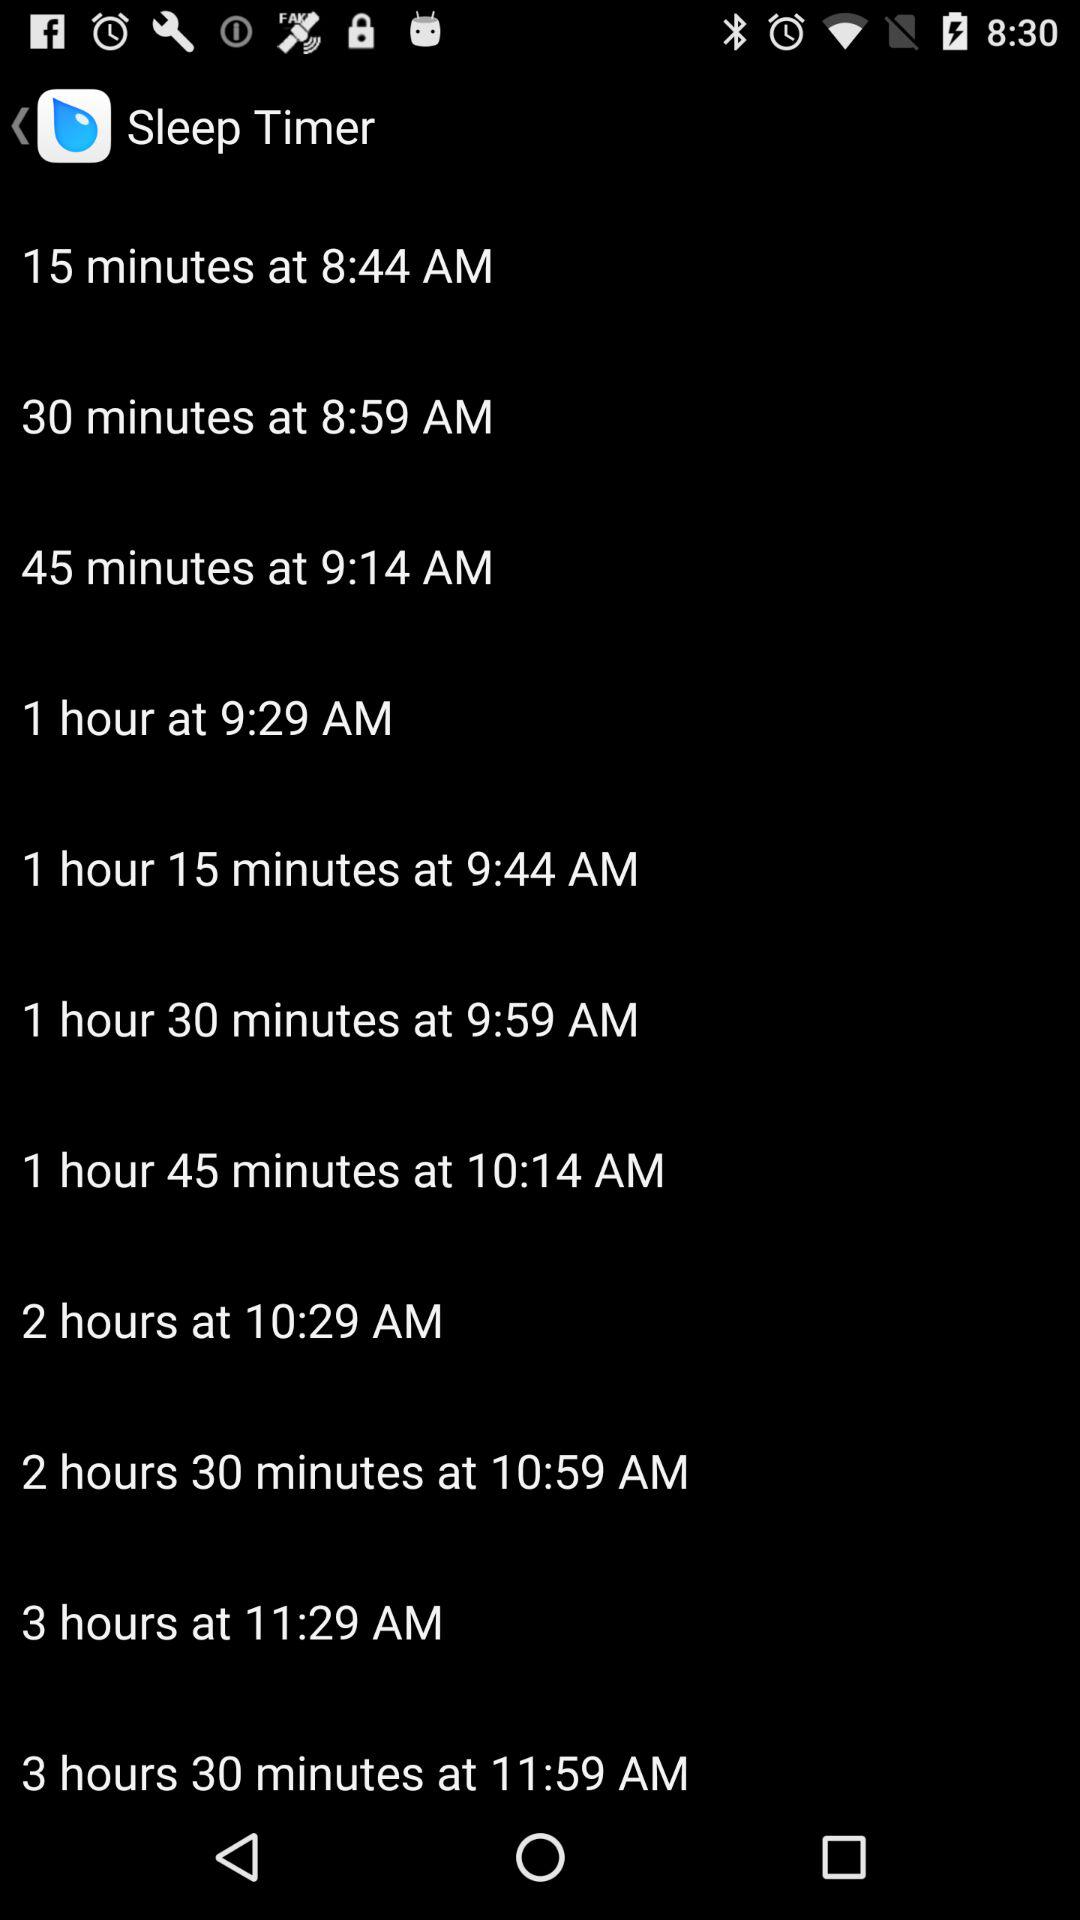How many minutes is the shortest sleep timer option?
Answer the question using a single word or phrase. 15 minutes 